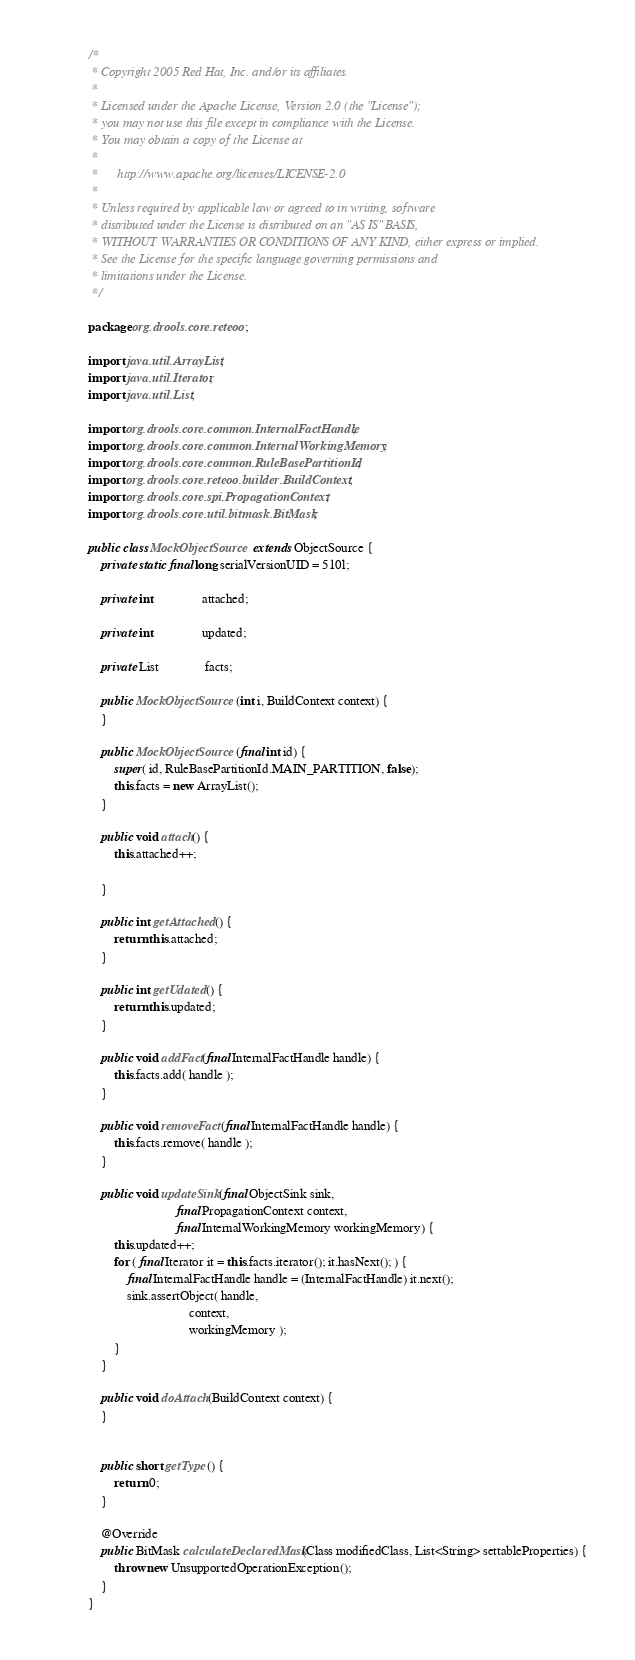<code> <loc_0><loc_0><loc_500><loc_500><_Java_>/*
 * Copyright 2005 Red Hat, Inc. and/or its affiliates.
 *
 * Licensed under the Apache License, Version 2.0 (the "License");
 * you may not use this file except in compliance with the License.
 * You may obtain a copy of the License at
 *
 *      http://www.apache.org/licenses/LICENSE-2.0
 *
 * Unless required by applicable law or agreed to in writing, software
 * distributed under the License is distributed on an "AS IS" BASIS,
 * WITHOUT WARRANTIES OR CONDITIONS OF ANY KIND, either express or implied.
 * See the License for the specific language governing permissions and
 * limitations under the License.
 */

package org.drools.core.reteoo;

import java.util.ArrayList;
import java.util.Iterator;
import java.util.List;

import org.drools.core.common.InternalFactHandle;
import org.drools.core.common.InternalWorkingMemory;
import org.drools.core.common.RuleBasePartitionId;
import org.drools.core.reteoo.builder.BuildContext;
import org.drools.core.spi.PropagationContext;
import org.drools.core.util.bitmask.BitMask;

public class MockObjectSource extends ObjectSource {
    private static final long serialVersionUID = 510l;

    private int               attached;

    private int               updated;

    private List              facts;

    public MockObjectSource(int i, BuildContext context) {
    }

    public MockObjectSource(final int id) {
        super( id, RuleBasePartitionId.MAIN_PARTITION, false);
        this.facts = new ArrayList();
    }

    public void attach() {
        this.attached++;

    }

    public int getAttached() {
        return this.attached;
    }

    public int getUdated() {
        return this.updated;
    }

    public void addFact(final InternalFactHandle handle) {
        this.facts.add( handle );
    }
    
    public void removeFact(final InternalFactHandle handle) {
        this.facts.remove( handle );
    }

    public void updateSink(final ObjectSink sink,
                           final PropagationContext context,
                           final InternalWorkingMemory workingMemory) {
        this.updated++;
        for ( final Iterator it = this.facts.iterator(); it.hasNext(); ) {
            final InternalFactHandle handle = (InternalFactHandle) it.next();
            sink.assertObject( handle,
                               context,
                               workingMemory );
        }
    }

    public void doAttach(BuildContext context) {
    }

   
    public short getType() {
        return 0;
    }
    
    @Override
    public BitMask calculateDeclaredMask(Class modifiedClass, List<String> settableProperties) {
        throw new UnsupportedOperationException();
    }
}
</code> 